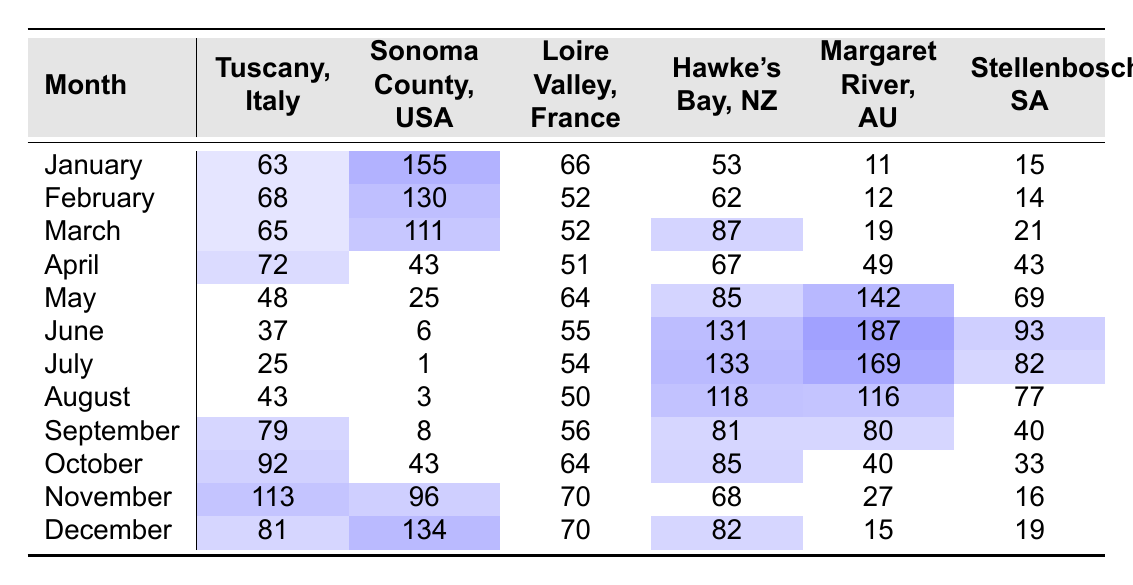What is the highest monthly rainfall recorded in Sonoma County, USA? The highest rainfall for Sonoma County is found by looking through the monthly values listed in the table. Scanning the rainfall data, January shows a value of 155, which is higher than any other month.
Answer: 155 Which region experiences the least rainfall in July? By examining the July column for all regions in the table, we find that Sonoma County has the least rainfall with a value of 1.
Answer: 1 What is the average rainfall in the Loire Valley, France over the year? To calculate the average, I sum the monthly rainfall for Loire Valley: (66 + 52 + 52 + 51 + 64 + 55 + 54 + 50 + 56 + 64 + 70 + 70) = 665. Since there are 12 months, I divide 665 by 12, which gives approximately 55.42.
Answer: 55.42 In which month does Hawke's Bay, New Zealand have the highest amount of rainfall? A look at the monthly values for Hawke's Bay indicates that June has the highest rainfall at 131, compared to the other months in the table.
Answer: June Is the rainfall in Margaret River, Australia greater in May or April? By reviewing the entries for May (142) and April (49) in the Margaret River row, it is clear that May has significantly higher rainfall than April.
Answer: Yes, May What is the total amount of rainfall for Stellenbosch, South Africa across the entire year? I sum the monthly rainfall for Stellenbosch: (15 + 14 + 21 + 43 + 69 + 93 + 82 + 77 + 40 + 33 + 16 + 19) = 542, which gives the total annual rainfall for this region.
Answer: 542 During which month does Tuscany, Italy receive more rainfall than the average across all regions? First, I need to find the average amount of rainfall per month across all regions. Adding the totals for each month (summing all 6 regions) and then dividing by 6 gives the monthly average of 70.33. Checking the Tuscany amounts, January (63), February (68), March (65), April (72), May (48), June (37), July (25), August (43), September (79), October (92), November (113), and December (81), I see that April (72) and November (113) are greater than the monthly average.
Answer: April and November Which region has the most consistent rainfall throughout the year? To assess consistency, examine the variability of rainfall across each region's monthly values. The Loire Valley shows relatively similar values (52 to 70) without significant fluctuations compared to the other regions.
Answer: Loire Valley 